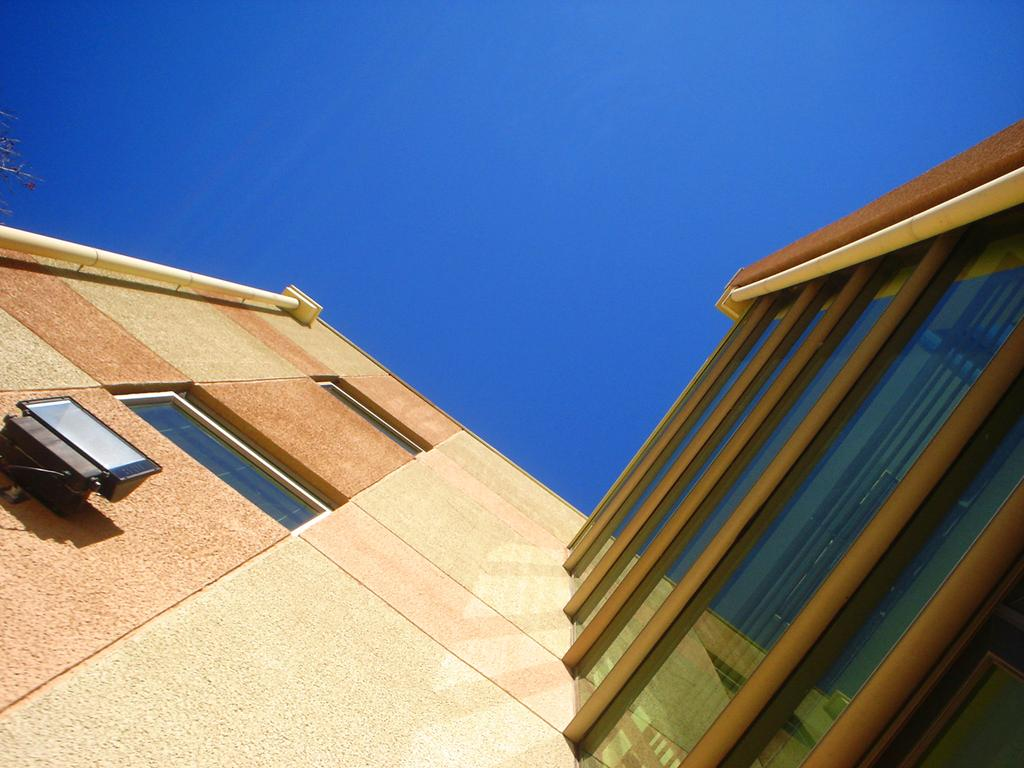What type of structure is present in the image? There is a building in the image. What can be seen above the building? The sky is visible above the building. What type of mark can be seen on the building in the image? There is no specific mark mentioned in the facts, and therefore no such mark can be observed. Is there a knife visible in the image? No, there is no knife present in the image. Can you see a baseball game happening in the image? No, there is no baseball game or any reference to sports in the image. 